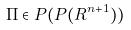<formula> <loc_0><loc_0><loc_500><loc_500>\Pi \in P ( P ( R ^ { n + 1 } ) )</formula> 